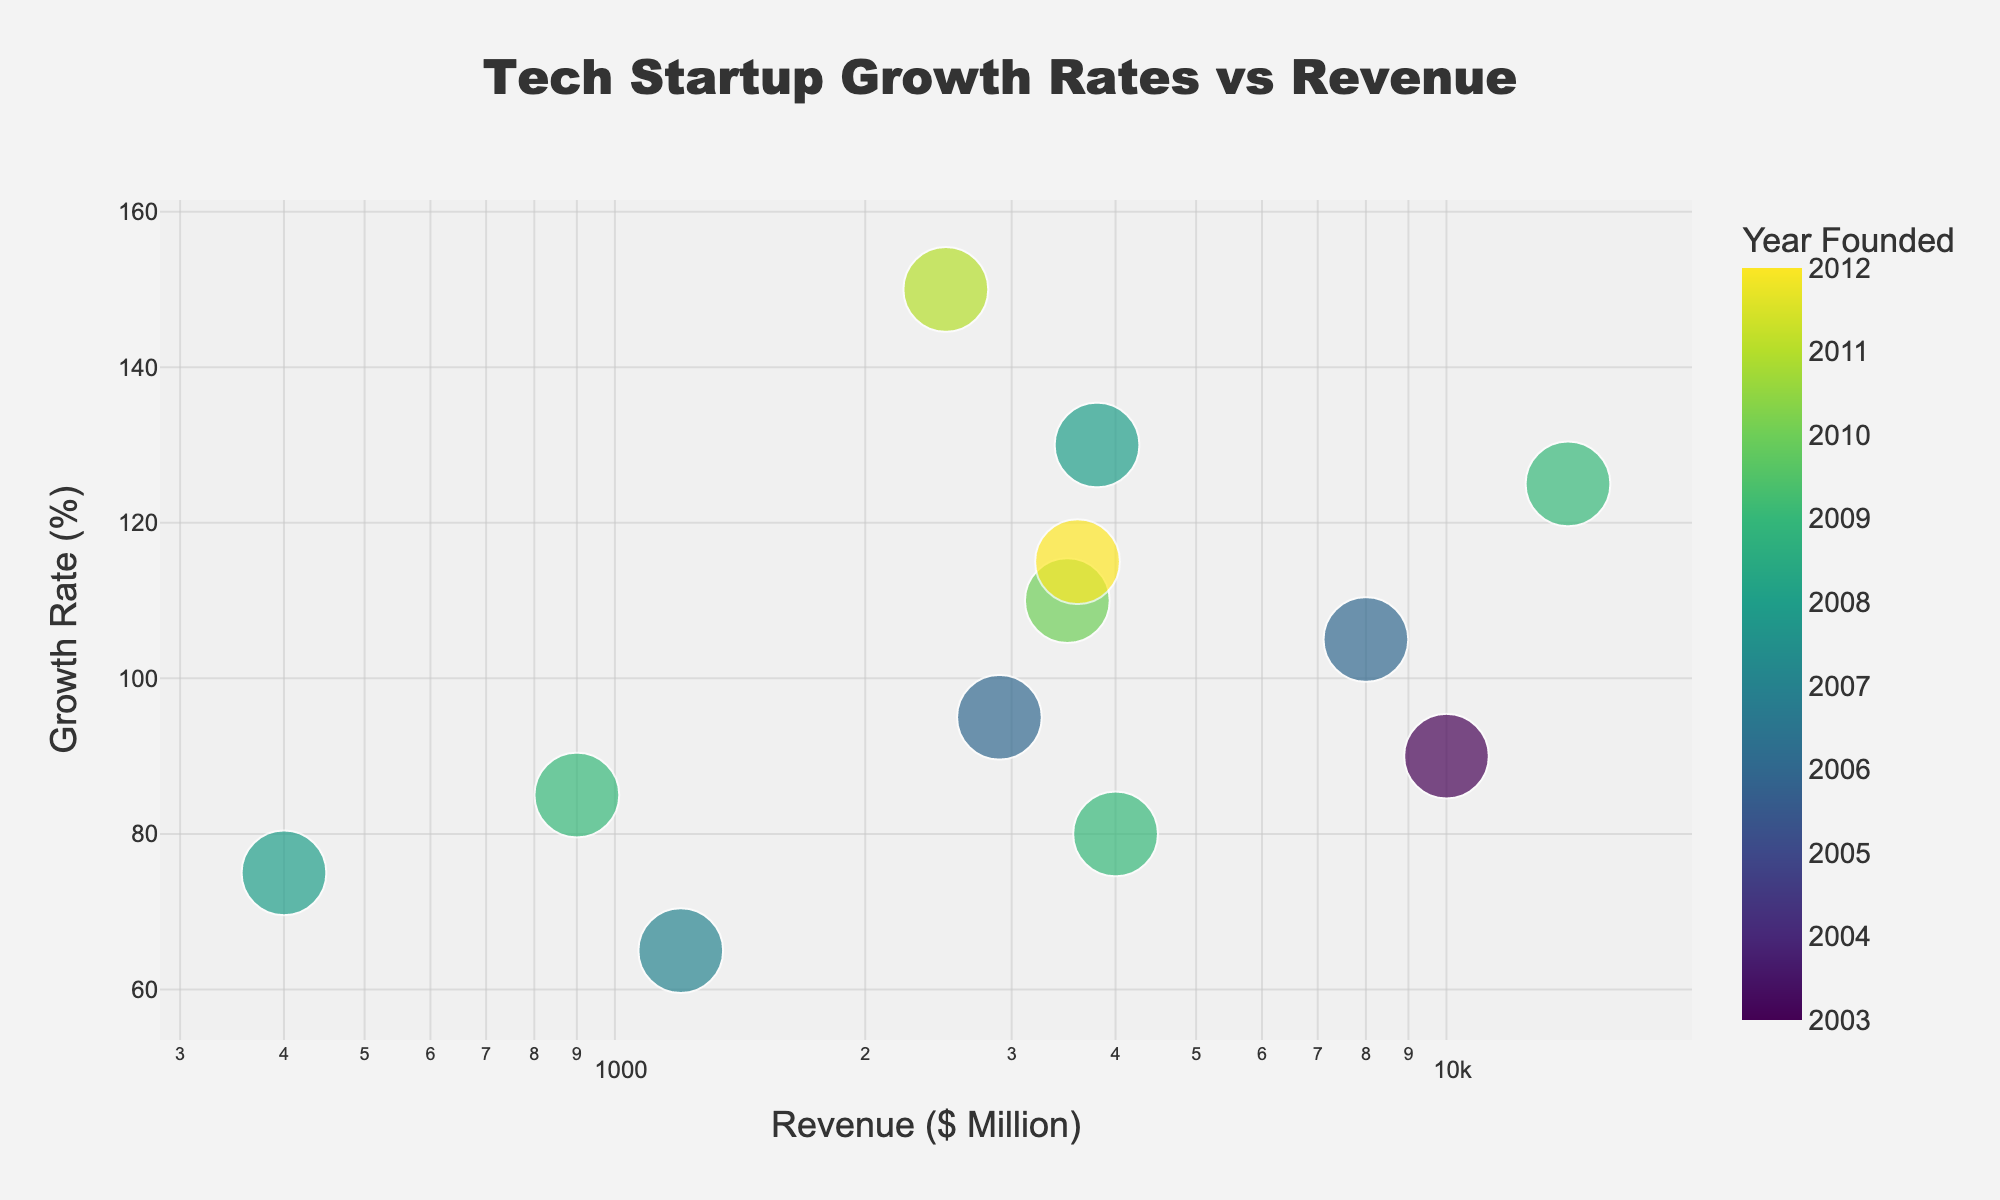What's the title of the plot? The title is positioned at the top center of the plot and is usually bold or larger in font for easy recognition. It serves to give an immediate context of what the figure represents. Here, the title reads "Tech Startup Growth Rates vs Revenue".
Answer: Tech Startup Growth Rates vs Revenue How many companies are represented in the scatter plot? By visually counting the number of individual data points (or company labels) in the figure, we can determine the total number of companies. Each label represents one company.
Answer: 12 Which company has the highest growth rate? The company with the highest growth rate will be the one with the highest y-axis value since the y-axis represents growth rates. By locating the highest point on the y-axis, we see it is for Zoom.
Answer: Zoom What's the grow rate range represented in the plot? By checking the y-axis values of the scatter plot from the lowest point to the highest point, we can identify the range. The lowest growth rate is 65% for Dropbox, and the highest is 150% for Zoom.
Answer: 65% to 150% What's the relationship between "Year Founded" and the size of the data points? Observing the plot, we note that the size of each data point correlates with the "Year Founded". Newer companies have larger dots, as denoted by the legend.
Answer: Newer companies have larger dots Which company has the highest revenue, and what is it approximately? The x-axis represents revenue. The company furthest to the right has the highest revenue. By locating the rightmost point on the x-axis, we see it is Uber with a revenue of approximately $14,000 million.
Answer: Uber, $14,000 million Compare the growth rates of Uber and Lyft. Which one has a higher growth rate? By locating both Uber and Lyft on the plot, we compare their positions concerning the y-axis. Uber is positioned slightly lower than Lyft on the y-axis.
Answer: Lyft Which companies have revenues between $1000 million and $5000 million and have a growth rate above 100%? First, locate the x-axis to find companies within the $1,000 million to $5,000 million range, then check their corresponding y-axis values to see which have a growth rate above 100%. These companies are Stripe, Airbnb, and Lyft.
Answer: Stripe, Airbnb, Lyft What's the average growth rate for companies with revenue above $3,000 million? Locate companies above the $3,000 million mark on the x-axis (Square, Shopify, Airbnb, Stripe, Palantir, Spotify, Uber, Lyft). Sum their growth rates (115+125+105+130+110+90+95+80) and divide by the number of companies (8). The average comes to 106%
Answer: 106% Why is the log scale used for the revenue axis, and how does it help in this plot? The log scale is used to manage a wide range of values, making it easier to visualize data that spans several orders of magnitude by compressing the scale. It highlights the proportional differences rather than the absolute differences, which is beneficial in financial data like revenue that varies significantly among companies.
Answer: To manage a wide range of values and highlight proportional differences 